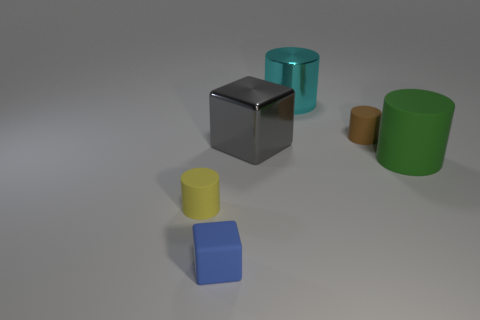How many things are either purple balls or rubber cylinders?
Your answer should be very brief. 3. Are there an equal number of big gray cubes behind the gray metallic cube and red metallic cylinders?
Offer a very short reply. Yes. Is there a large gray metallic cube in front of the small brown object on the right side of the tiny matte object to the left of the blue thing?
Keep it short and to the point. Yes. There is another object that is made of the same material as the large cyan object; what is its color?
Offer a terse response. Gray. How many balls are either small things or big cyan objects?
Give a very brief answer. 0. What size is the shiny cylinder that is to the right of the object that is in front of the rubber cylinder to the left of the small brown rubber cylinder?
Provide a succinct answer. Large. What is the shape of the brown object that is the same size as the blue rubber cube?
Offer a very short reply. Cylinder. The small blue matte object has what shape?
Provide a short and direct response. Cube. Is the small cylinder behind the tiny yellow rubber cylinder made of the same material as the cyan cylinder?
Ensure brevity in your answer.  No. There is a matte thing right of the small matte cylinder that is right of the small yellow cylinder; what is its size?
Offer a terse response. Large. 